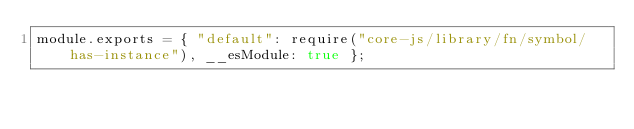<code> <loc_0><loc_0><loc_500><loc_500><_JavaScript_>module.exports = { "default": require("core-js/library/fn/symbol/has-instance"), __esModule: true };</code> 